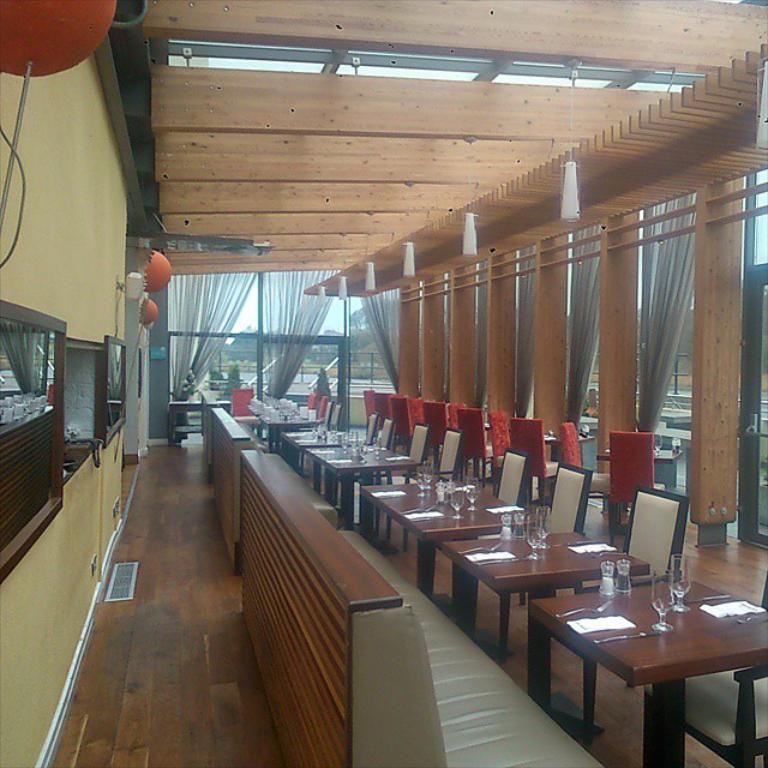Please provide a concise description of this image. In this picture we can observe a room with dining tables, sofas and chairs around these tables. We can observe glasses and tissues placed on these brown color tables. We can observe curtains and glass doors in the background. On the right side we can observe a wall which is in cream color. 